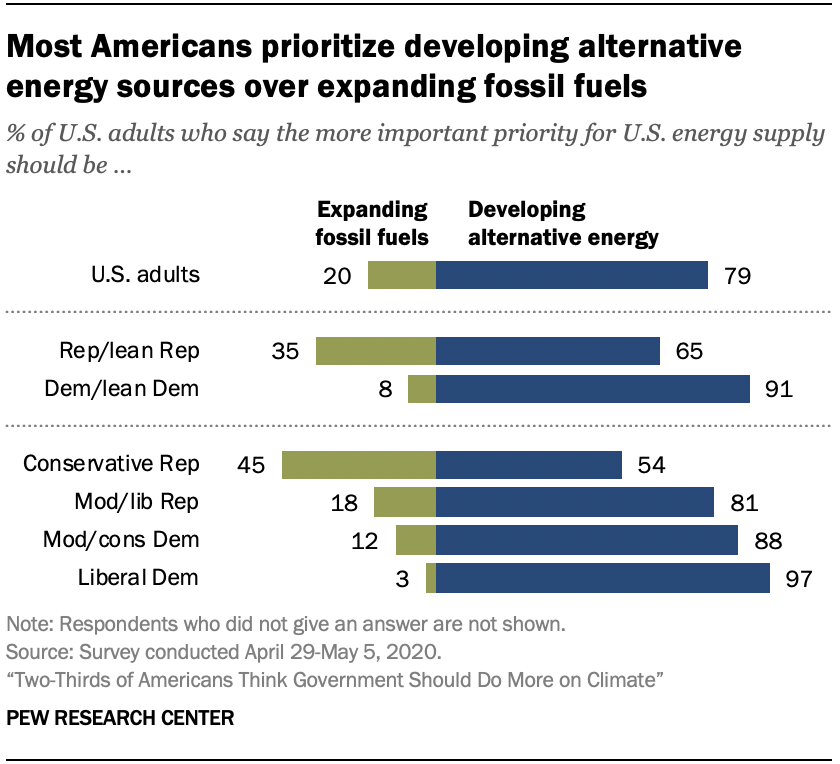Indicate a few pertinent items in this graphic. There are multiple blue bars with a value below 70. The lowest value of the green bar is 0.03, with the range being between 0.03 and 0.12. 